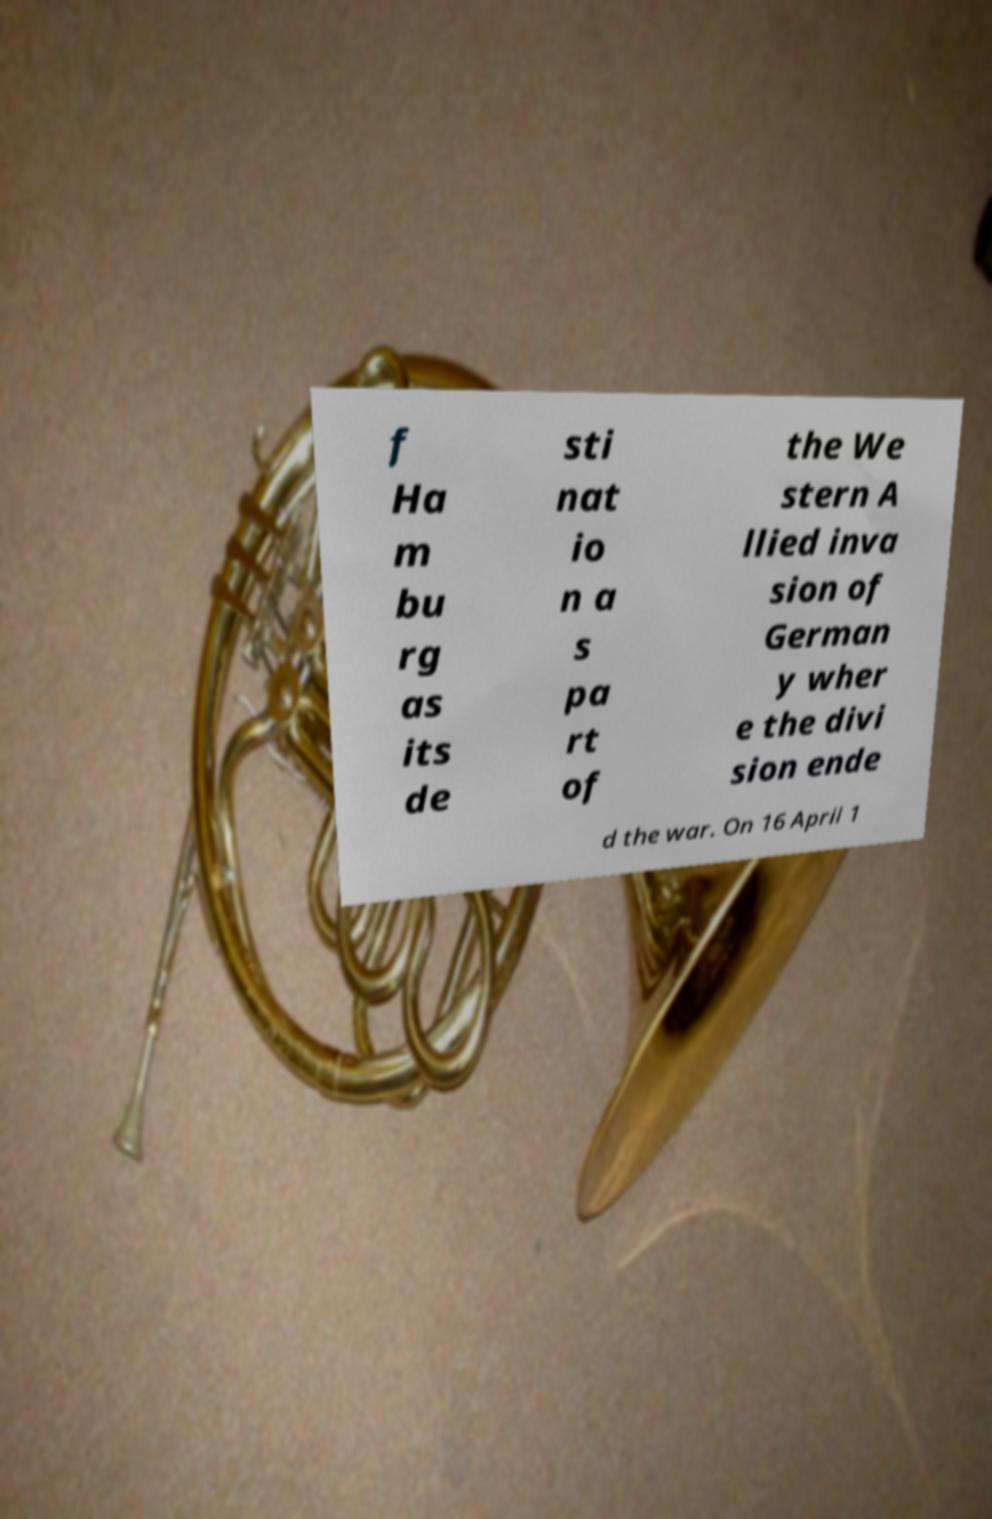Can you read and provide the text displayed in the image?This photo seems to have some interesting text. Can you extract and type it out for me? f Ha m bu rg as its de sti nat io n a s pa rt of the We stern A llied inva sion of German y wher e the divi sion ende d the war. On 16 April 1 